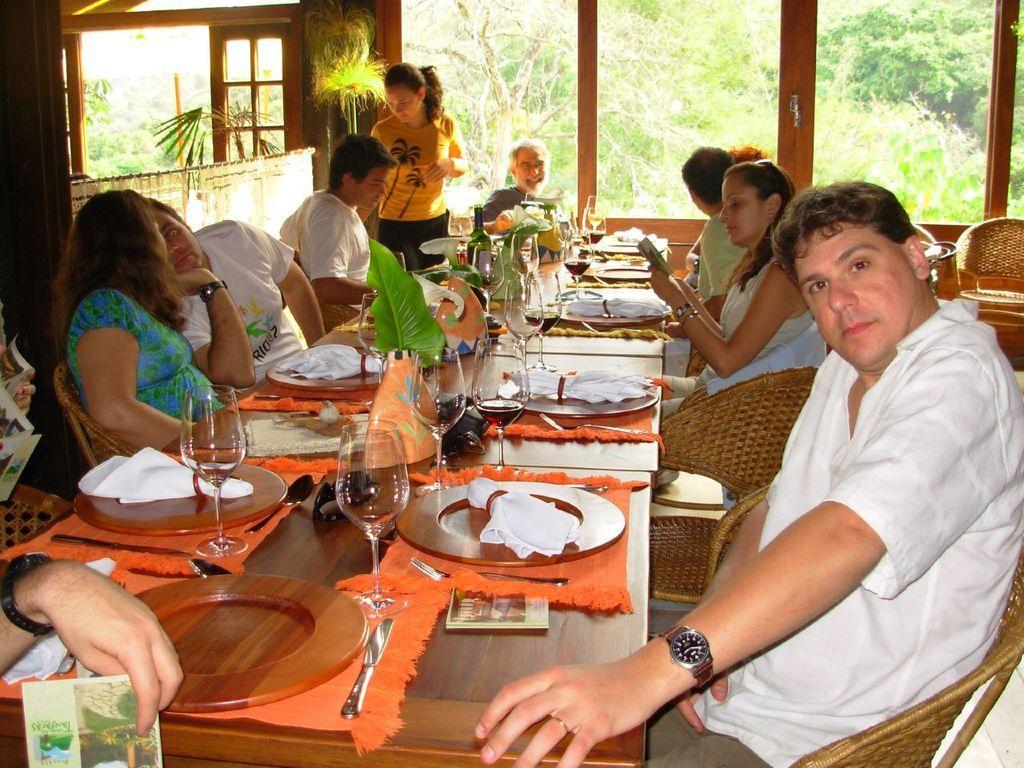Describe this image in one or two sentences. These persons are sitting on the chairs and this person standing. We can see plates,cloth,leaves,glasses,spoons,knife on the table. we can see book holding with hand. On the background we can see glass window and door,from this glass window we can see trees. 